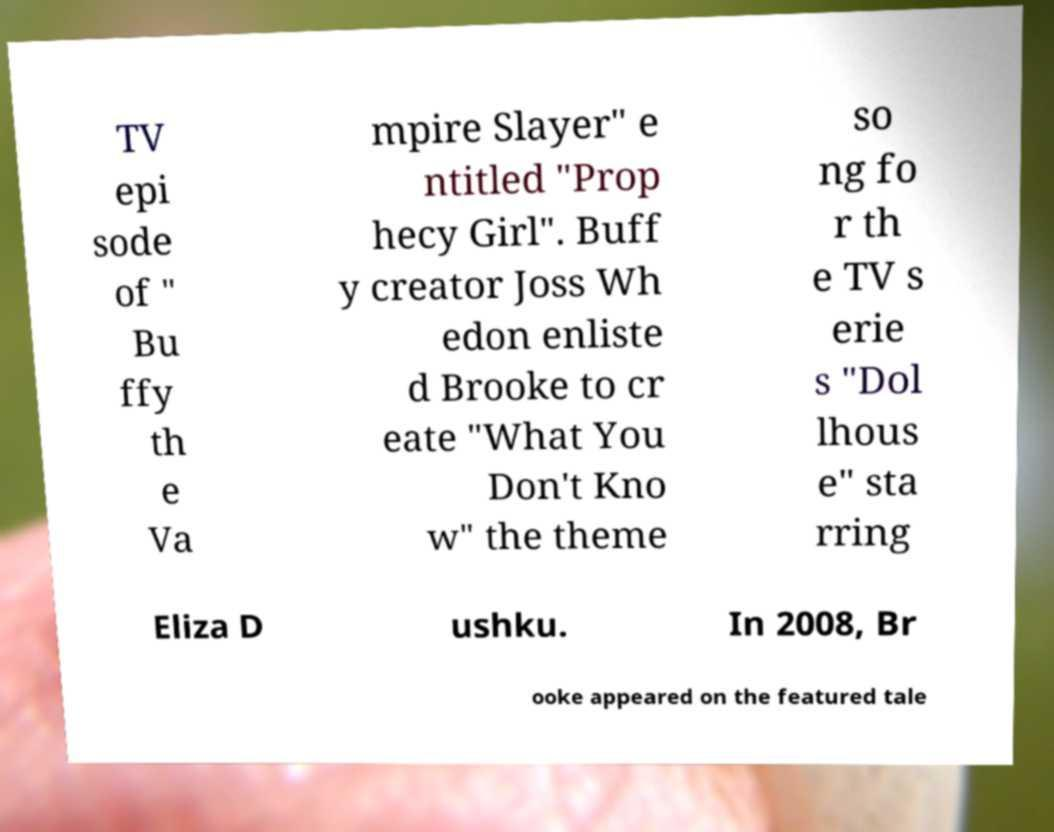Can you read and provide the text displayed in the image?This photo seems to have some interesting text. Can you extract and type it out for me? TV epi sode of " Bu ffy th e Va mpire Slayer" e ntitled "Prop hecy Girl". Buff y creator Joss Wh edon enliste d Brooke to cr eate "What You Don't Kno w" the theme so ng fo r th e TV s erie s "Dol lhous e" sta rring Eliza D ushku. In 2008, Br ooke appeared on the featured tale 